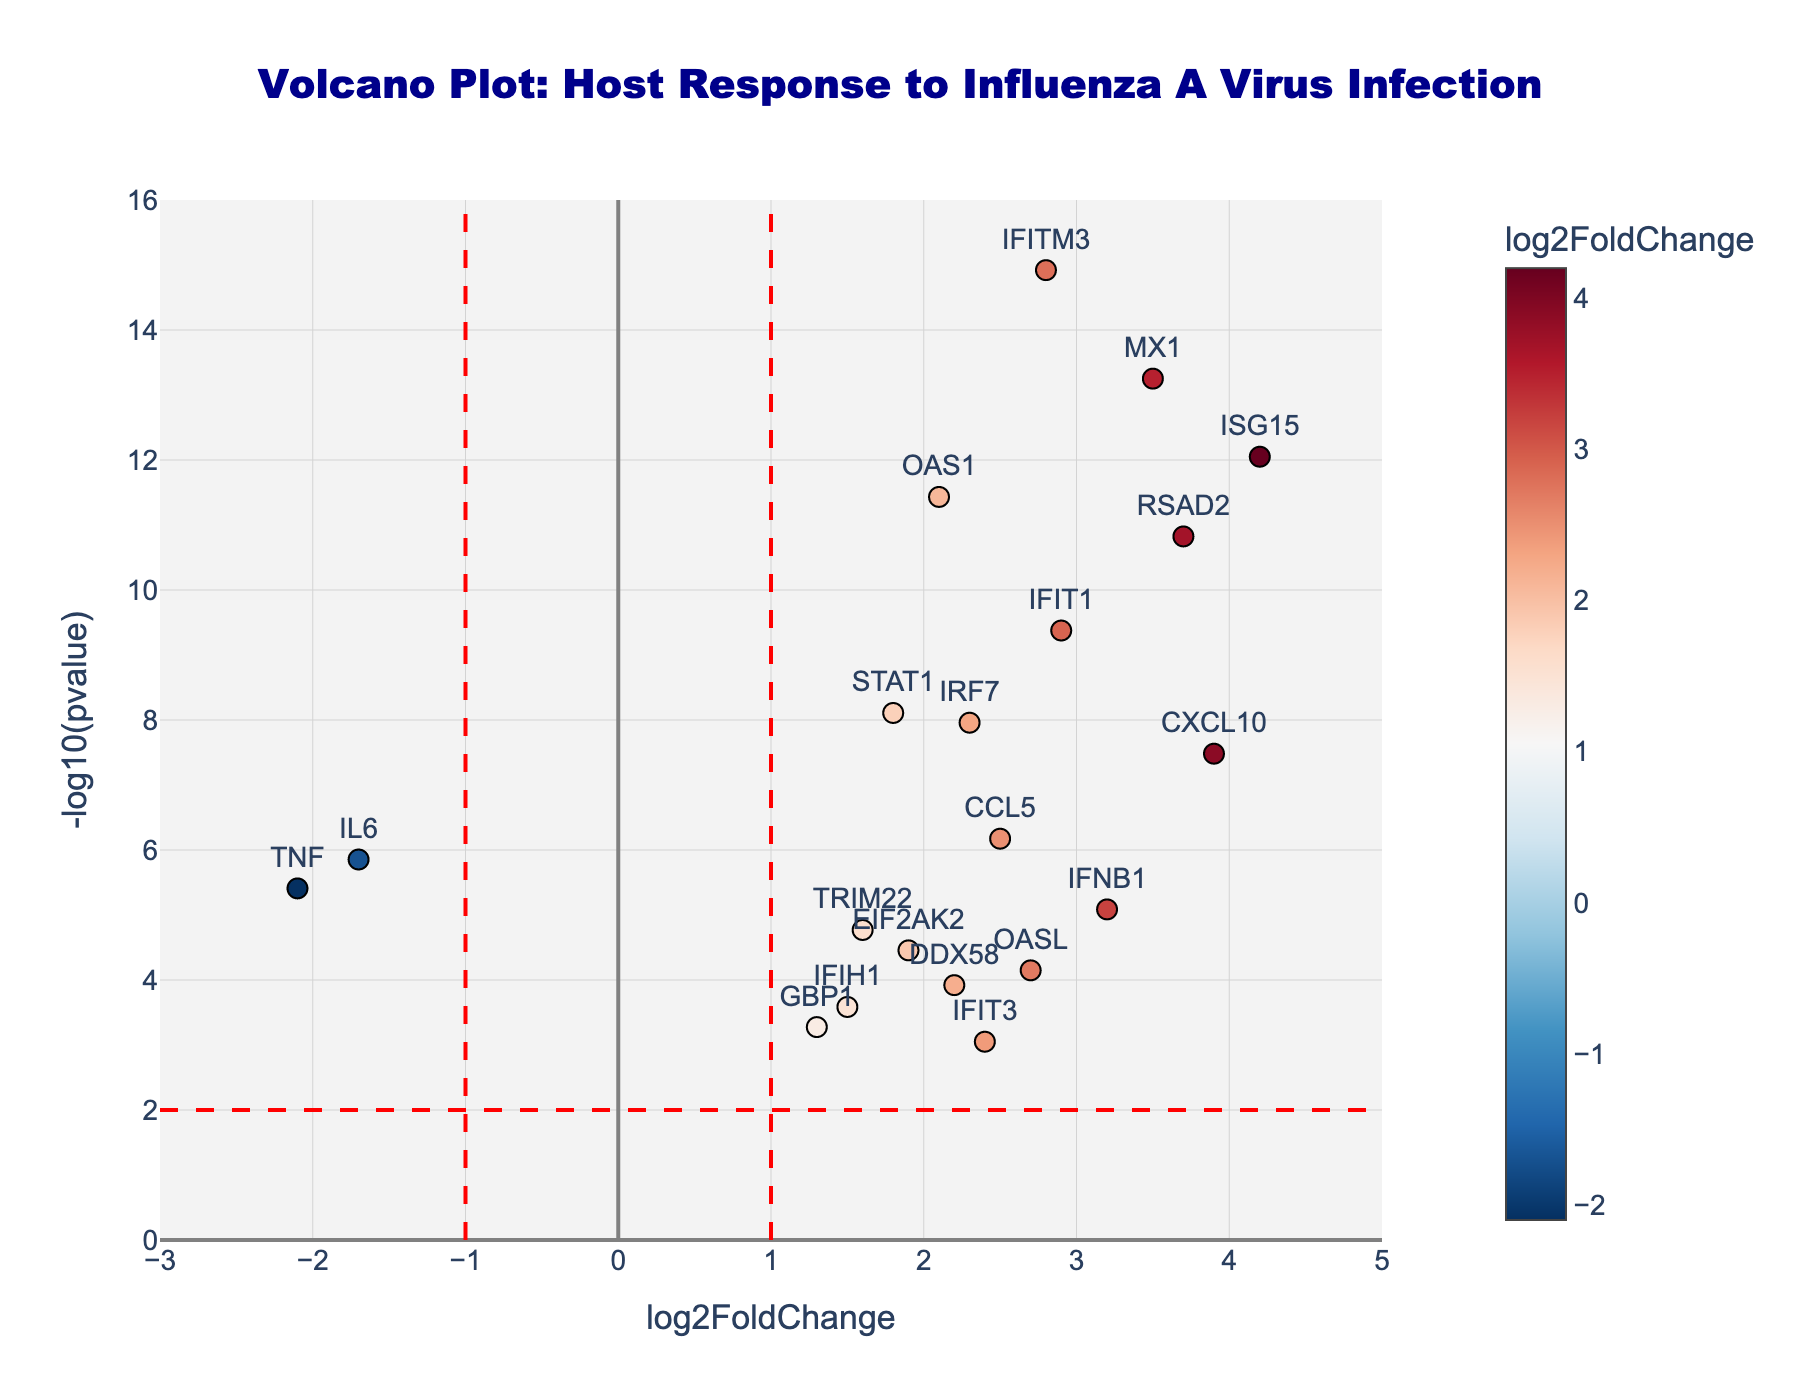What does the title of the figure say? The title is located at the top of the figure, centered and in a larger, bold font. It provides a brief description of the data being visualized. In this case, the title is "Volcano Plot: Host Response to Influenza A Virus Infection."
Answer: "Volcano Plot: Host Response to Influenza A Virus Infection" What's the range of log2FoldChange on the x-axis? The x-axis is labeled "log2FoldChange" and represents the fold change in gene expression. The axis ranges from -3 to 5 as indicated by the tick marks and grid lines.
Answer: -3 to 5 How many genes have a -log10(pvalue) greater than or equal to 2? To answer this, count the number of points above the horizontal red dashed line at y = 2. Visual inspection shows there are 20 genes above this threshold.
Answer: 20 genes Which gene has the highest -log10(pvalue)? The -log10(pvalue) is plotted on the y-axis. The gene with the highest value is at the top of the plot. Referring to the plot, "IFITM3" has the highest -log10(pvalue).
Answer: IFITM3 What's the color of the gene with the lowest log2FoldChange? The gene with the lowest log2FoldChange is the farthest left on the x-axis. That gene is "TNF," which is colored based on a gradient where lower log2FoldChange values trend towards blue. Thus, "TNF" is colored in blue.
Answer: Blue Among the highly significant genes (pvalue < 0.01), which one has the most negative log2FoldChange? The red horizontal line at y = 2 corresponds to pvalue = 0.01. The gene below this line with the most leftward position will have the most negative log2FoldChange. This gene is "TNF."
Answer: TNF Are there more upregulated or downregulated genes at pvalue < 1e-5? Upregulated genes have positive log2FoldChange values (right side of the plot), while downregulated genes have negative values (left side). Count the points above the pvalue < 1e-5 line at x = +/- 1. More genes are located on the right, indicating more upregulated genes.
Answer: More upregulated genes What is the range of -log10(pvalue) for the gene "IFIT1"? Locate "IFIT1" by its text label in the plot. Then, check its y-position. The plot shows "IFIT1" is slightly more than 10 on the y-axis.
Answer: A bit more than 10 